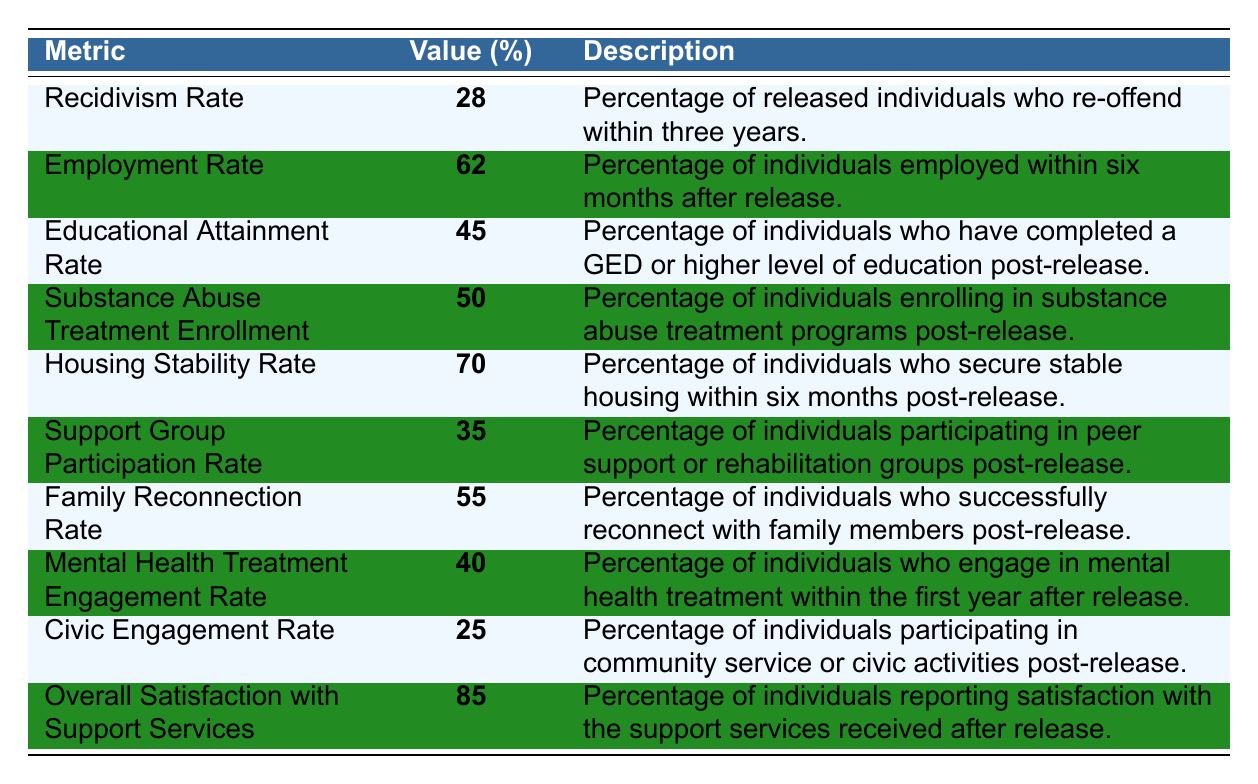What is the recidivism rate? The recidivism rate is specifically listed in the table as 28%.
Answer: 28% What percentage of individuals found employment within six months after release? The employment rate is given in the table as 62%.
Answer: 62% What is the difference between the housing stability rate and the civic engagement rate? The housing stability rate is 70%, and the civic engagement rate is 25%. The difference is 70 - 25 = 45.
Answer: 45 Is the overall satisfaction with support services above 80%? The table indicates that the overall satisfaction rate is 85%, which is indeed above 80%.
Answer: Yes What percentage of individuals participated in support groups post-release? The participation rate for support groups is indicated in the table as 35%.
Answer: 35% What is the average percentage of employment, educational attainment, and family reconnection rates? The employment rate is 62%, educational attainment is 45%, and family reconnection is 55%. Summing these gives 62 + 45 + 55 = 162, and dividing by 3 gives an average of 162 / 3 = 54%.
Answer: 54% Which metric has the highest percentage value? The table shows that the overall satisfaction with support services has the highest percentage at 85%.
Answer: 85% How many metrics have a value above 50%? The metrics with values above 50% are employment rate (62%), housing stability rate (70%), and overall satisfaction (85%), totaling 3 metrics.
Answer: 3 What percentage of individuals engaged in mental health treatment post-release? The mental health treatment engagement rate is listed as 40% in the table.
Answer: 40% If 100 individuals were released, how many would be expected to enroll in substance abuse treatment programs based on the given percentage? The substance abuse treatment enrollment rate is 50%. Therefore, if 100 individuals were released, 50 would be expected to enroll in treatment programs (100 * 0.50 = 50).
Answer: 50 